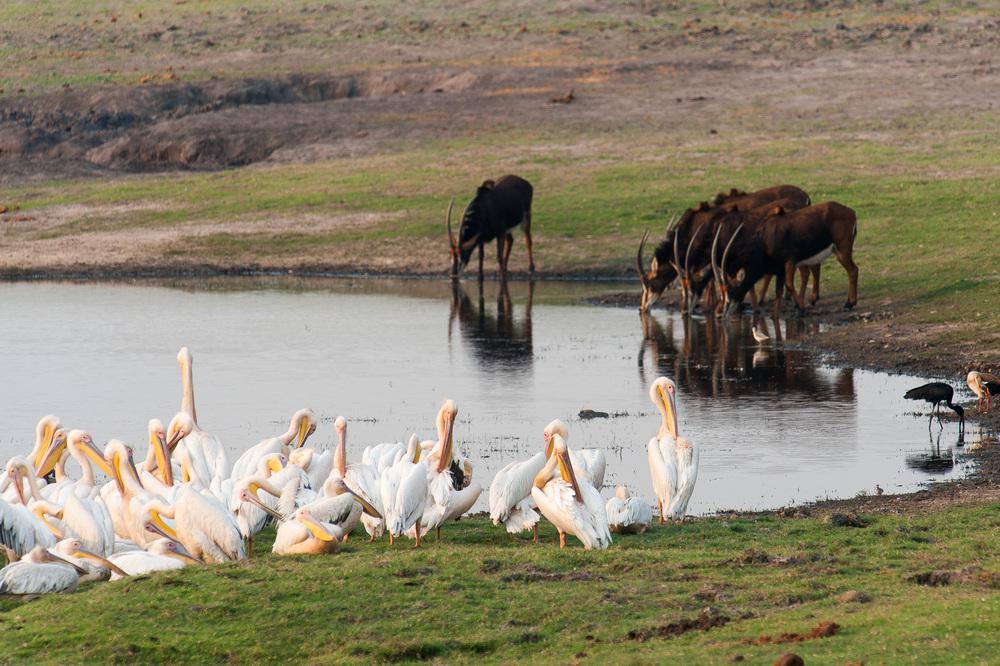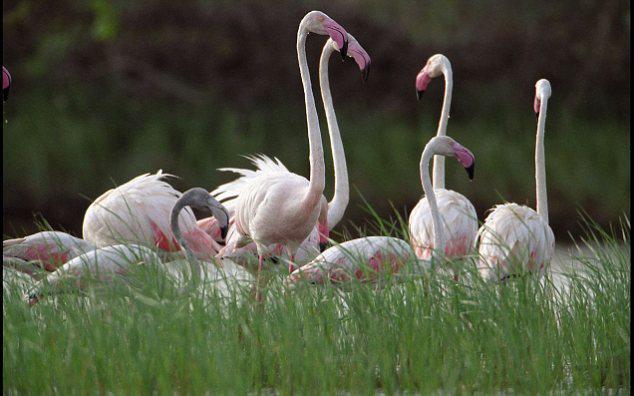The first image is the image on the left, the second image is the image on the right. Given the left and right images, does the statement "One of the images contain exactly 4 storks." hold true? Answer yes or no. No. The first image is the image on the left, the second image is the image on the right. Examine the images to the left and right. Is the description "One of the images shows an animal with the birds." accurate? Answer yes or no. Yes. 